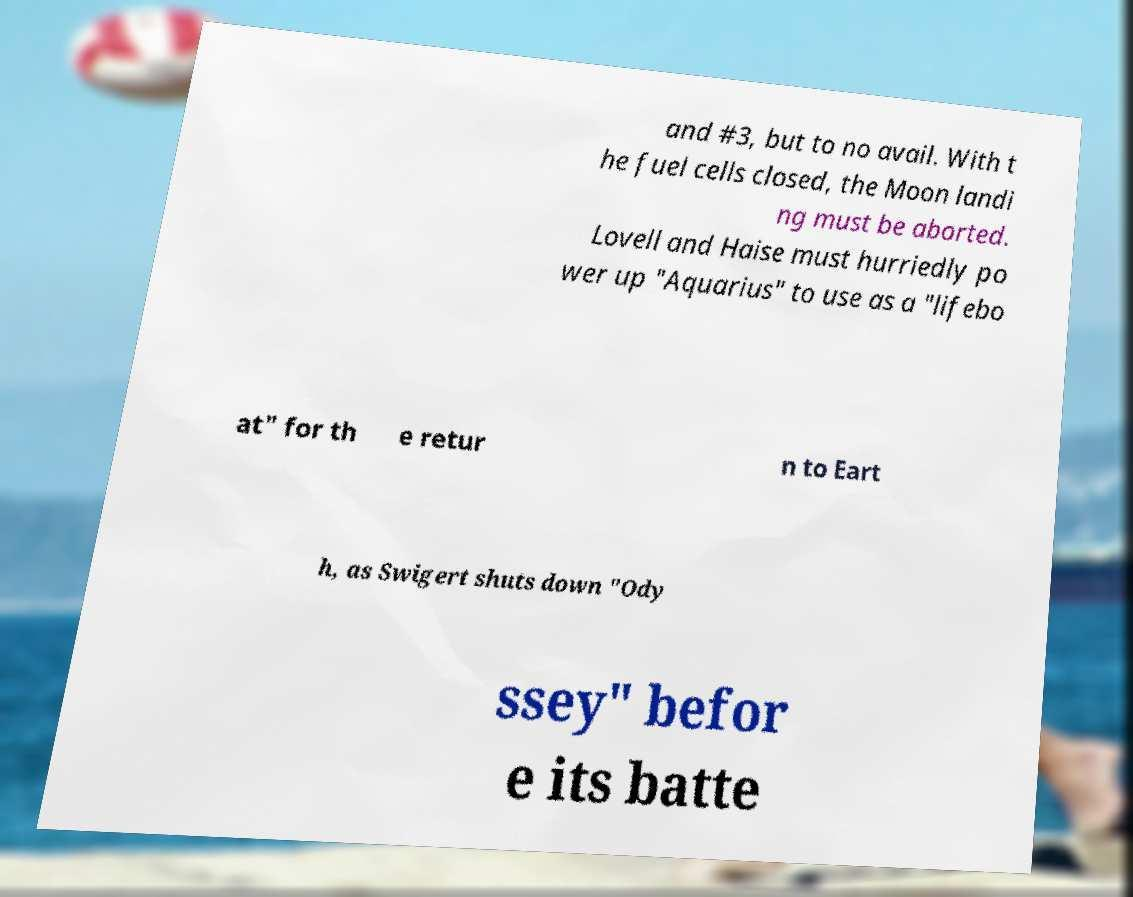Can you read and provide the text displayed in the image?This photo seems to have some interesting text. Can you extract and type it out for me? and #3, but to no avail. With t he fuel cells closed, the Moon landi ng must be aborted. Lovell and Haise must hurriedly po wer up "Aquarius" to use as a "lifebo at" for th e retur n to Eart h, as Swigert shuts down "Ody ssey" befor e its batte 